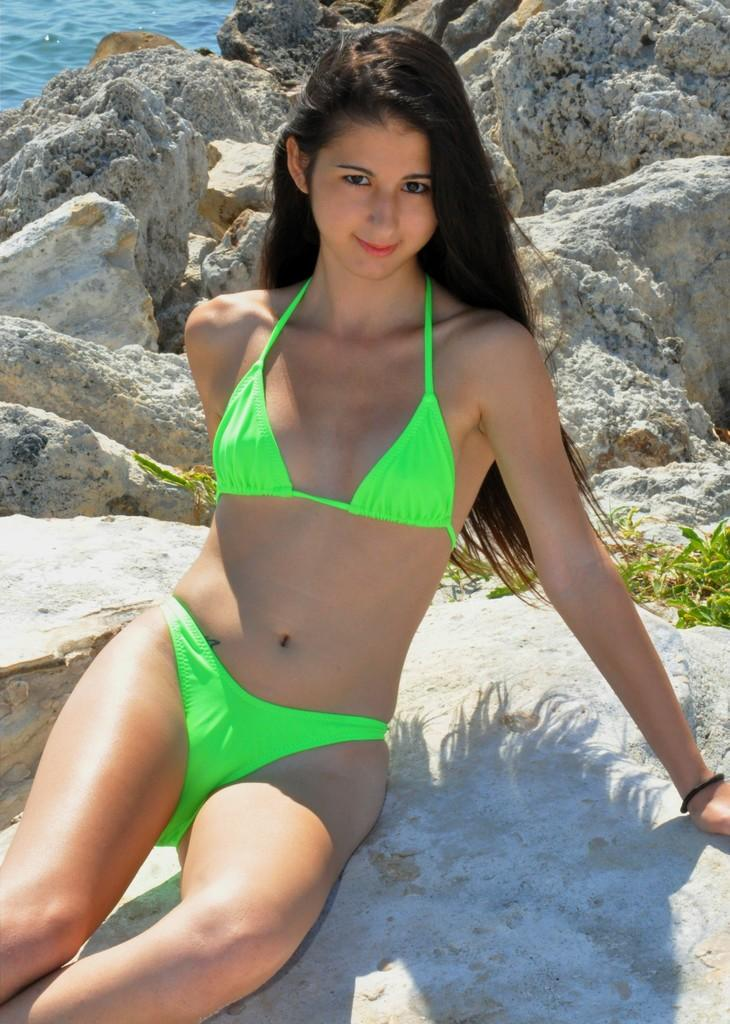Who is present in the image? There is a woman in the image. What is the woman doing in the image? The woman is sitting on a rock. What can be seen in the background of the image? There are rocks, grass, and water visible in the background of the image. What type of crown is the woman wearing in the image? There is no crown present in the image; the woman is not wearing any headgear. 